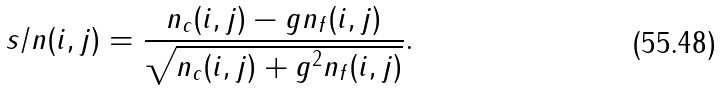<formula> <loc_0><loc_0><loc_500><loc_500>s / n ( i , j ) = \frac { n _ { c } ( i , j ) - g n _ { f } ( i , j ) } { \sqrt { n _ { c } ( i , j ) + g ^ { 2 } n _ { f } ( i , j ) } } .</formula> 